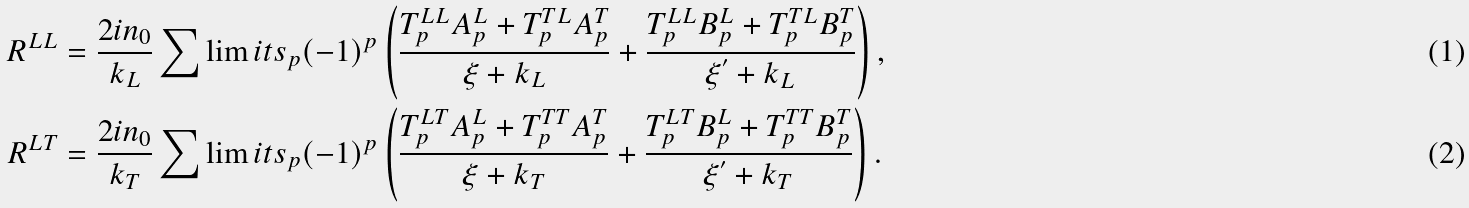<formula> <loc_0><loc_0><loc_500><loc_500>R ^ { L L } & = \frac { 2 i n _ { 0 } } { k _ { L } } \sum \lim i t s _ { p } ( - 1 ) ^ { p } \left ( \frac { T _ { p } ^ { L L } A _ { p } ^ { L } + T _ { p } ^ { T L } A _ { p } ^ { T } } { \xi + k _ { L } } + \frac { T _ { p } ^ { L L } B _ { p } ^ { L } + T _ { p } ^ { T L } B _ { p } ^ { T } } { \xi ^ { ^ { \prime } } + k _ { L } } \right ) , \\ R ^ { L T } & = \frac { 2 i n _ { 0 } } { k _ { T } } \sum \lim i t s _ { p } ( - 1 ) ^ { p } \left ( \frac { T _ { p } ^ { L T } A _ { p } ^ { L } + T _ { p } ^ { T T } A _ { p } ^ { T } } { \xi + k _ { T } } + \frac { T _ { p } ^ { L T } B _ { p } ^ { L } + T _ { p } ^ { T T } B _ { p } ^ { T } } { \xi ^ { ^ { \prime } } + k _ { T } } \right ) .</formula> 